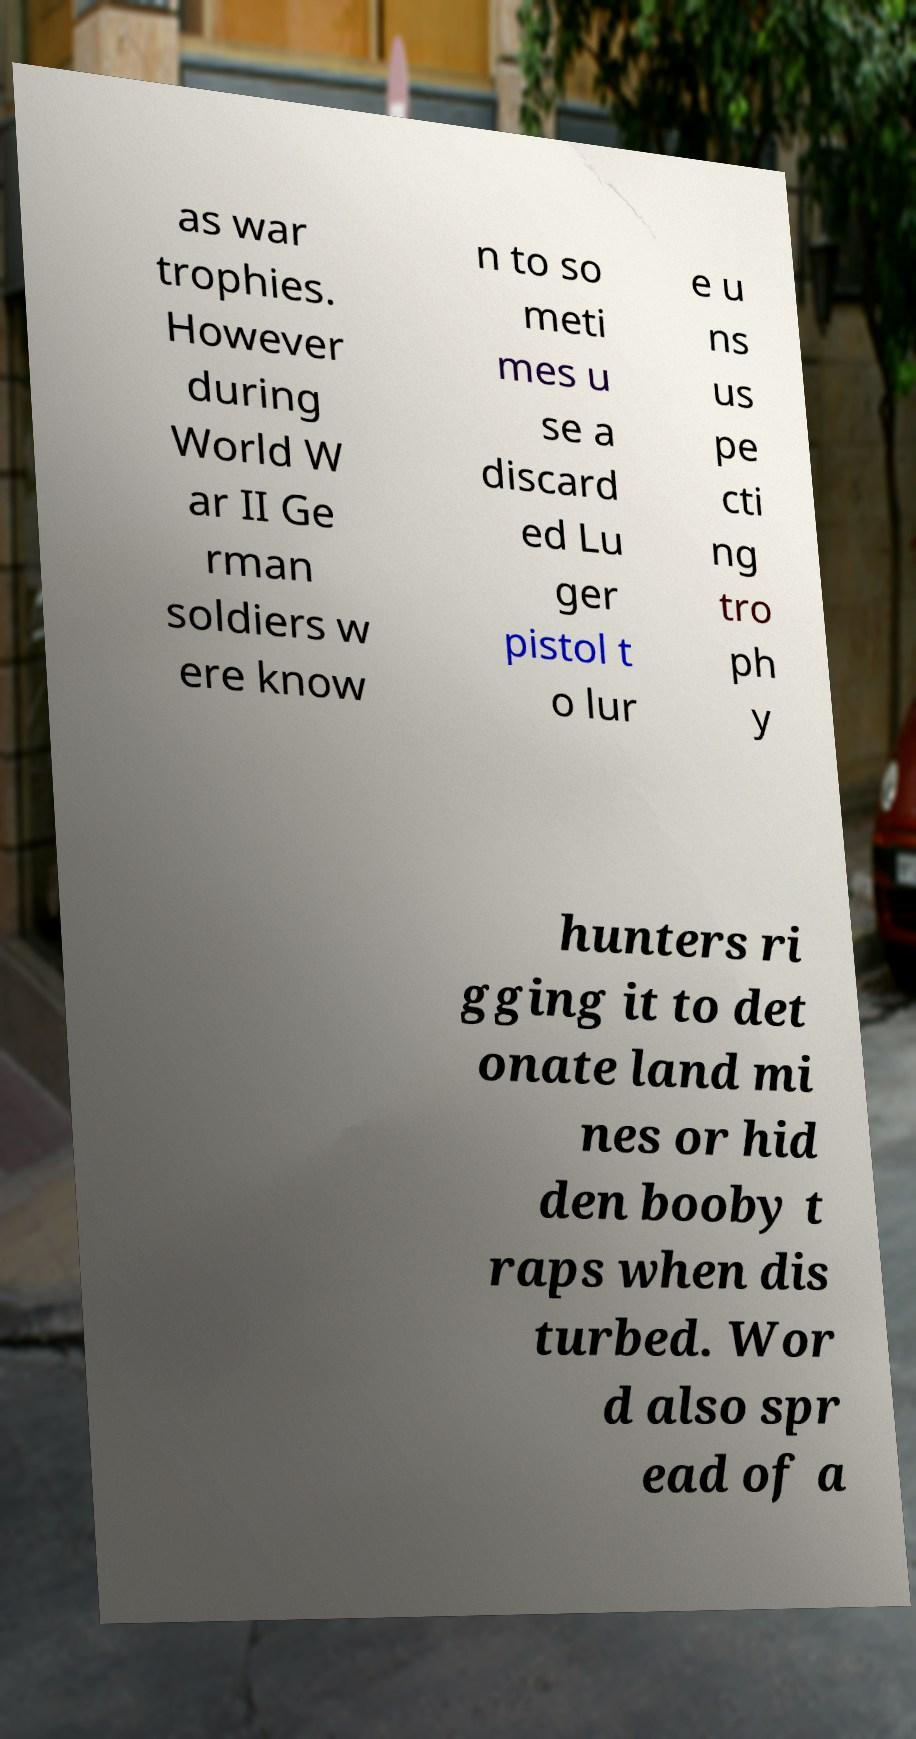Could you extract and type out the text from this image? as war trophies. However during World W ar II Ge rman soldiers w ere know n to so meti mes u se a discard ed Lu ger pistol t o lur e u ns us pe cti ng tro ph y hunters ri gging it to det onate land mi nes or hid den booby t raps when dis turbed. Wor d also spr ead of a 